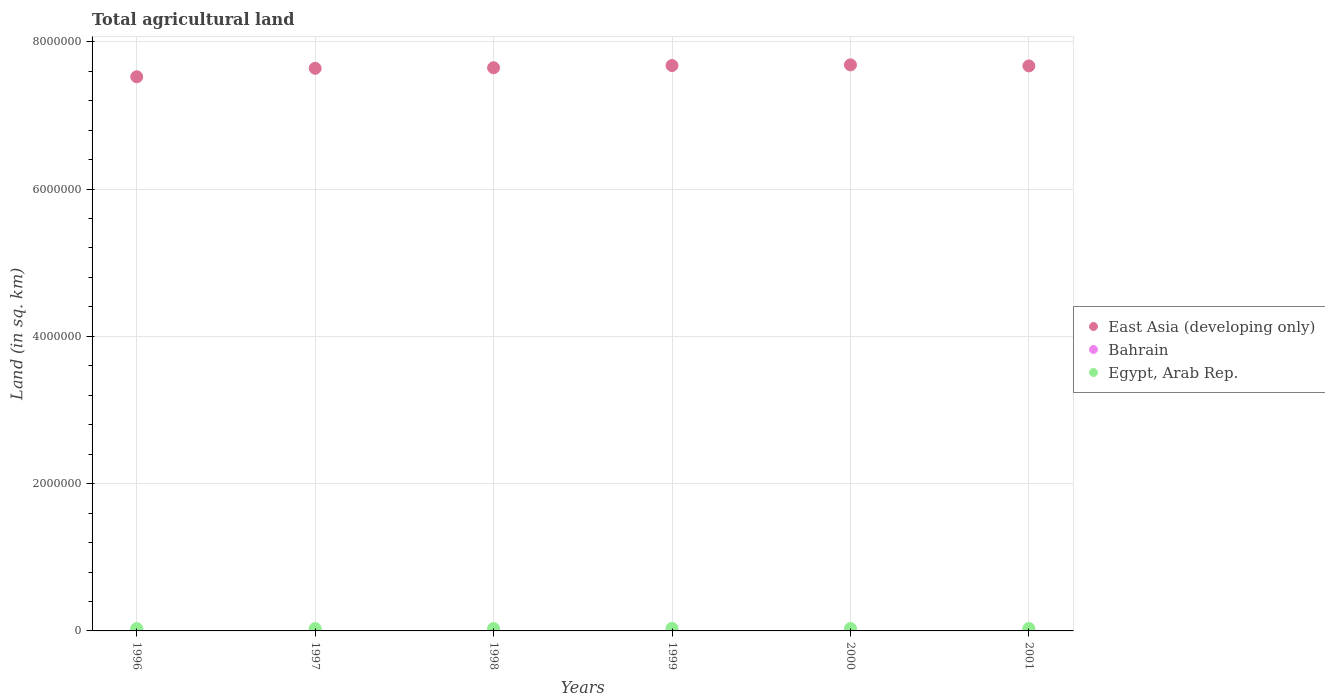How many different coloured dotlines are there?
Ensure brevity in your answer.  3. Across all years, what is the minimum total agricultural land in East Asia (developing only)?
Offer a terse response. 7.52e+06. In which year was the total agricultural land in Bahrain minimum?
Your answer should be compact. 1996. What is the total total agricultural land in Egypt, Arab Rep. in the graph?
Offer a terse response. 1.98e+05. What is the difference between the total agricultural land in East Asia (developing only) in 1996 and that in 1997?
Ensure brevity in your answer.  -1.15e+05. What is the difference between the total agricultural land in East Asia (developing only) in 1998 and the total agricultural land in Egypt, Arab Rep. in 1999?
Give a very brief answer. 7.61e+06. What is the average total agricultural land in Bahrain per year?
Your response must be concise. 92.33. In the year 1999, what is the difference between the total agricultural land in Egypt, Arab Rep. and total agricultural land in Bahrain?
Offer a very short reply. 3.47e+04. What is the ratio of the total agricultural land in East Asia (developing only) in 1996 to that in 2001?
Your answer should be very brief. 0.98. Is the total agricultural land in Bahrain in 1998 less than that in 2001?
Provide a short and direct response. Yes. What is the difference between the highest and the second highest total agricultural land in Egypt, Arab Rep.?
Your answer should be very brief. 1450. What is the difference between the highest and the lowest total agricultural land in Bahrain?
Keep it short and to the point. 10. In how many years, is the total agricultural land in East Asia (developing only) greater than the average total agricultural land in East Asia (developing only) taken over all years?
Ensure brevity in your answer.  4. Is the total agricultural land in East Asia (developing only) strictly less than the total agricultural land in Egypt, Arab Rep. over the years?
Your response must be concise. No. How many years are there in the graph?
Give a very brief answer. 6. Are the values on the major ticks of Y-axis written in scientific E-notation?
Keep it short and to the point. No. Does the graph contain any zero values?
Give a very brief answer. No. Does the graph contain grids?
Ensure brevity in your answer.  Yes. How many legend labels are there?
Your response must be concise. 3. How are the legend labels stacked?
Your answer should be very brief. Vertical. What is the title of the graph?
Make the answer very short. Total agricultural land. What is the label or title of the X-axis?
Offer a terse response. Years. What is the label or title of the Y-axis?
Provide a succinct answer. Land (in sq. km). What is the Land (in sq. km) in East Asia (developing only) in 1996?
Provide a short and direct response. 7.52e+06. What is the Land (in sq. km) of Egypt, Arab Rep. in 1996?
Your answer should be very brief. 3.18e+04. What is the Land (in sq. km) of East Asia (developing only) in 1997?
Your response must be concise. 7.64e+06. What is the Land (in sq. km) of Egypt, Arab Rep. in 1997?
Provide a short and direct response. 3.24e+04. What is the Land (in sq. km) in East Asia (developing only) in 1998?
Offer a very short reply. 7.65e+06. What is the Land (in sq. km) in Bahrain in 1998?
Your response must be concise. 90. What is the Land (in sq. km) in Egypt, Arab Rep. in 1998?
Give a very brief answer. 3.26e+04. What is the Land (in sq. km) of East Asia (developing only) in 1999?
Provide a short and direct response. 7.68e+06. What is the Land (in sq. km) in Bahrain in 1999?
Provide a short and direct response. 100. What is the Land (in sq. km) in Egypt, Arab Rep. in 1999?
Offer a very short reply. 3.48e+04. What is the Land (in sq. km) in East Asia (developing only) in 2000?
Your response must be concise. 7.69e+06. What is the Land (in sq. km) of Bahrain in 2000?
Provide a succinct answer. 92. What is the Land (in sq. km) in Egypt, Arab Rep. in 2000?
Give a very brief answer. 3.29e+04. What is the Land (in sq. km) in East Asia (developing only) in 2001?
Provide a succinct answer. 7.67e+06. What is the Land (in sq. km) in Bahrain in 2001?
Make the answer very short. 92. What is the Land (in sq. km) of Egypt, Arab Rep. in 2001?
Provide a succinct answer. 3.34e+04. Across all years, what is the maximum Land (in sq. km) of East Asia (developing only)?
Your response must be concise. 7.69e+06. Across all years, what is the maximum Land (in sq. km) of Egypt, Arab Rep.?
Offer a very short reply. 3.48e+04. Across all years, what is the minimum Land (in sq. km) of East Asia (developing only)?
Your response must be concise. 7.52e+06. Across all years, what is the minimum Land (in sq. km) in Egypt, Arab Rep.?
Provide a succinct answer. 3.18e+04. What is the total Land (in sq. km) in East Asia (developing only) in the graph?
Provide a succinct answer. 4.58e+07. What is the total Land (in sq. km) in Bahrain in the graph?
Offer a very short reply. 554. What is the total Land (in sq. km) of Egypt, Arab Rep. in the graph?
Make the answer very short. 1.98e+05. What is the difference between the Land (in sq. km) in East Asia (developing only) in 1996 and that in 1997?
Your response must be concise. -1.15e+05. What is the difference between the Land (in sq. km) of Bahrain in 1996 and that in 1997?
Make the answer very short. 0. What is the difference between the Land (in sq. km) of Egypt, Arab Rep. in 1996 and that in 1997?
Give a very brief answer. -684.6. What is the difference between the Land (in sq. km) of East Asia (developing only) in 1996 and that in 1998?
Ensure brevity in your answer.  -1.22e+05. What is the difference between the Land (in sq. km) of Bahrain in 1996 and that in 1998?
Your answer should be very brief. 0. What is the difference between the Land (in sq. km) in Egypt, Arab Rep. in 1996 and that in 1998?
Offer a very short reply. -831.6. What is the difference between the Land (in sq. km) of East Asia (developing only) in 1996 and that in 1999?
Offer a very short reply. -1.52e+05. What is the difference between the Land (in sq. km) in Bahrain in 1996 and that in 1999?
Ensure brevity in your answer.  -10. What is the difference between the Land (in sq. km) of Egypt, Arab Rep. in 1996 and that in 1999?
Your answer should be compact. -3065.4. What is the difference between the Land (in sq. km) of East Asia (developing only) in 1996 and that in 2000?
Make the answer very short. -1.61e+05. What is the difference between the Land (in sq. km) of Bahrain in 1996 and that in 2000?
Your answer should be compact. -2. What is the difference between the Land (in sq. km) in Egypt, Arab Rep. in 1996 and that in 2000?
Ensure brevity in your answer.  -1145.4. What is the difference between the Land (in sq. km) in East Asia (developing only) in 1996 and that in 2001?
Your response must be concise. -1.47e+05. What is the difference between the Land (in sq. km) of Bahrain in 1996 and that in 2001?
Give a very brief answer. -2. What is the difference between the Land (in sq. km) of Egypt, Arab Rep. in 1996 and that in 2001?
Ensure brevity in your answer.  -1615.4. What is the difference between the Land (in sq. km) of East Asia (developing only) in 1997 and that in 1998?
Provide a short and direct response. -7489. What is the difference between the Land (in sq. km) of Egypt, Arab Rep. in 1997 and that in 1998?
Give a very brief answer. -147. What is the difference between the Land (in sq. km) in East Asia (developing only) in 1997 and that in 1999?
Provide a succinct answer. -3.74e+04. What is the difference between the Land (in sq. km) in Bahrain in 1997 and that in 1999?
Keep it short and to the point. -10. What is the difference between the Land (in sq. km) in Egypt, Arab Rep. in 1997 and that in 1999?
Provide a short and direct response. -2380.8. What is the difference between the Land (in sq. km) of East Asia (developing only) in 1997 and that in 2000?
Provide a short and direct response. -4.65e+04. What is the difference between the Land (in sq. km) of Bahrain in 1997 and that in 2000?
Your response must be concise. -2. What is the difference between the Land (in sq. km) of Egypt, Arab Rep. in 1997 and that in 2000?
Provide a short and direct response. -460.8. What is the difference between the Land (in sq. km) in East Asia (developing only) in 1997 and that in 2001?
Make the answer very short. -3.25e+04. What is the difference between the Land (in sq. km) in Bahrain in 1997 and that in 2001?
Ensure brevity in your answer.  -2. What is the difference between the Land (in sq. km) of Egypt, Arab Rep. in 1997 and that in 2001?
Provide a short and direct response. -930.8. What is the difference between the Land (in sq. km) in East Asia (developing only) in 1998 and that in 1999?
Make the answer very short. -2.99e+04. What is the difference between the Land (in sq. km) in Bahrain in 1998 and that in 1999?
Provide a short and direct response. -10. What is the difference between the Land (in sq. km) of Egypt, Arab Rep. in 1998 and that in 1999?
Keep it short and to the point. -2233.8. What is the difference between the Land (in sq. km) in East Asia (developing only) in 1998 and that in 2000?
Offer a terse response. -3.90e+04. What is the difference between the Land (in sq. km) of Egypt, Arab Rep. in 1998 and that in 2000?
Keep it short and to the point. -313.8. What is the difference between the Land (in sq. km) of East Asia (developing only) in 1998 and that in 2001?
Offer a very short reply. -2.50e+04. What is the difference between the Land (in sq. km) of Bahrain in 1998 and that in 2001?
Provide a succinct answer. -2. What is the difference between the Land (in sq. km) in Egypt, Arab Rep. in 1998 and that in 2001?
Provide a short and direct response. -783.8. What is the difference between the Land (in sq. km) of East Asia (developing only) in 1999 and that in 2000?
Offer a terse response. -9175.1. What is the difference between the Land (in sq. km) of Egypt, Arab Rep. in 1999 and that in 2000?
Make the answer very short. 1920. What is the difference between the Land (in sq. km) in East Asia (developing only) in 1999 and that in 2001?
Your answer should be very brief. 4894.9. What is the difference between the Land (in sq. km) in Egypt, Arab Rep. in 1999 and that in 2001?
Provide a short and direct response. 1450. What is the difference between the Land (in sq. km) in East Asia (developing only) in 2000 and that in 2001?
Make the answer very short. 1.41e+04. What is the difference between the Land (in sq. km) in Egypt, Arab Rep. in 2000 and that in 2001?
Provide a succinct answer. -470. What is the difference between the Land (in sq. km) of East Asia (developing only) in 1996 and the Land (in sq. km) of Bahrain in 1997?
Offer a very short reply. 7.52e+06. What is the difference between the Land (in sq. km) in East Asia (developing only) in 1996 and the Land (in sq. km) in Egypt, Arab Rep. in 1997?
Your response must be concise. 7.49e+06. What is the difference between the Land (in sq. km) of Bahrain in 1996 and the Land (in sq. km) of Egypt, Arab Rep. in 1997?
Provide a short and direct response. -3.24e+04. What is the difference between the Land (in sq. km) in East Asia (developing only) in 1996 and the Land (in sq. km) in Bahrain in 1998?
Make the answer very short. 7.52e+06. What is the difference between the Land (in sq. km) in East Asia (developing only) in 1996 and the Land (in sq. km) in Egypt, Arab Rep. in 1998?
Your answer should be compact. 7.49e+06. What is the difference between the Land (in sq. km) in Bahrain in 1996 and the Land (in sq. km) in Egypt, Arab Rep. in 1998?
Ensure brevity in your answer.  -3.25e+04. What is the difference between the Land (in sq. km) in East Asia (developing only) in 1996 and the Land (in sq. km) in Bahrain in 1999?
Give a very brief answer. 7.52e+06. What is the difference between the Land (in sq. km) in East Asia (developing only) in 1996 and the Land (in sq. km) in Egypt, Arab Rep. in 1999?
Give a very brief answer. 7.49e+06. What is the difference between the Land (in sq. km) in Bahrain in 1996 and the Land (in sq. km) in Egypt, Arab Rep. in 1999?
Your answer should be very brief. -3.47e+04. What is the difference between the Land (in sq. km) of East Asia (developing only) in 1996 and the Land (in sq. km) of Bahrain in 2000?
Keep it short and to the point. 7.52e+06. What is the difference between the Land (in sq. km) in East Asia (developing only) in 1996 and the Land (in sq. km) in Egypt, Arab Rep. in 2000?
Offer a terse response. 7.49e+06. What is the difference between the Land (in sq. km) of Bahrain in 1996 and the Land (in sq. km) of Egypt, Arab Rep. in 2000?
Offer a terse response. -3.28e+04. What is the difference between the Land (in sq. km) in East Asia (developing only) in 1996 and the Land (in sq. km) in Bahrain in 2001?
Your answer should be very brief. 7.52e+06. What is the difference between the Land (in sq. km) of East Asia (developing only) in 1996 and the Land (in sq. km) of Egypt, Arab Rep. in 2001?
Provide a succinct answer. 7.49e+06. What is the difference between the Land (in sq. km) of Bahrain in 1996 and the Land (in sq. km) of Egypt, Arab Rep. in 2001?
Provide a succinct answer. -3.33e+04. What is the difference between the Land (in sq. km) of East Asia (developing only) in 1997 and the Land (in sq. km) of Bahrain in 1998?
Give a very brief answer. 7.64e+06. What is the difference between the Land (in sq. km) in East Asia (developing only) in 1997 and the Land (in sq. km) in Egypt, Arab Rep. in 1998?
Keep it short and to the point. 7.61e+06. What is the difference between the Land (in sq. km) of Bahrain in 1997 and the Land (in sq. km) of Egypt, Arab Rep. in 1998?
Ensure brevity in your answer.  -3.25e+04. What is the difference between the Land (in sq. km) of East Asia (developing only) in 1997 and the Land (in sq. km) of Bahrain in 1999?
Your answer should be compact. 7.64e+06. What is the difference between the Land (in sq. km) of East Asia (developing only) in 1997 and the Land (in sq. km) of Egypt, Arab Rep. in 1999?
Ensure brevity in your answer.  7.61e+06. What is the difference between the Land (in sq. km) in Bahrain in 1997 and the Land (in sq. km) in Egypt, Arab Rep. in 1999?
Provide a succinct answer. -3.47e+04. What is the difference between the Land (in sq. km) in East Asia (developing only) in 1997 and the Land (in sq. km) in Bahrain in 2000?
Keep it short and to the point. 7.64e+06. What is the difference between the Land (in sq. km) in East Asia (developing only) in 1997 and the Land (in sq. km) in Egypt, Arab Rep. in 2000?
Give a very brief answer. 7.61e+06. What is the difference between the Land (in sq. km) of Bahrain in 1997 and the Land (in sq. km) of Egypt, Arab Rep. in 2000?
Give a very brief answer. -3.28e+04. What is the difference between the Land (in sq. km) in East Asia (developing only) in 1997 and the Land (in sq. km) in Bahrain in 2001?
Offer a terse response. 7.64e+06. What is the difference between the Land (in sq. km) in East Asia (developing only) in 1997 and the Land (in sq. km) in Egypt, Arab Rep. in 2001?
Provide a short and direct response. 7.61e+06. What is the difference between the Land (in sq. km) in Bahrain in 1997 and the Land (in sq. km) in Egypt, Arab Rep. in 2001?
Ensure brevity in your answer.  -3.33e+04. What is the difference between the Land (in sq. km) of East Asia (developing only) in 1998 and the Land (in sq. km) of Bahrain in 1999?
Provide a short and direct response. 7.65e+06. What is the difference between the Land (in sq. km) of East Asia (developing only) in 1998 and the Land (in sq. km) of Egypt, Arab Rep. in 1999?
Your response must be concise. 7.61e+06. What is the difference between the Land (in sq. km) of Bahrain in 1998 and the Land (in sq. km) of Egypt, Arab Rep. in 1999?
Ensure brevity in your answer.  -3.47e+04. What is the difference between the Land (in sq. km) in East Asia (developing only) in 1998 and the Land (in sq. km) in Bahrain in 2000?
Provide a succinct answer. 7.65e+06. What is the difference between the Land (in sq. km) of East Asia (developing only) in 1998 and the Land (in sq. km) of Egypt, Arab Rep. in 2000?
Give a very brief answer. 7.61e+06. What is the difference between the Land (in sq. km) of Bahrain in 1998 and the Land (in sq. km) of Egypt, Arab Rep. in 2000?
Provide a succinct answer. -3.28e+04. What is the difference between the Land (in sq. km) of East Asia (developing only) in 1998 and the Land (in sq. km) of Bahrain in 2001?
Offer a very short reply. 7.65e+06. What is the difference between the Land (in sq. km) in East Asia (developing only) in 1998 and the Land (in sq. km) in Egypt, Arab Rep. in 2001?
Give a very brief answer. 7.61e+06. What is the difference between the Land (in sq. km) of Bahrain in 1998 and the Land (in sq. km) of Egypt, Arab Rep. in 2001?
Offer a very short reply. -3.33e+04. What is the difference between the Land (in sq. km) in East Asia (developing only) in 1999 and the Land (in sq. km) in Bahrain in 2000?
Keep it short and to the point. 7.68e+06. What is the difference between the Land (in sq. km) of East Asia (developing only) in 1999 and the Land (in sq. km) of Egypt, Arab Rep. in 2000?
Offer a very short reply. 7.64e+06. What is the difference between the Land (in sq. km) of Bahrain in 1999 and the Land (in sq. km) of Egypt, Arab Rep. in 2000?
Give a very brief answer. -3.28e+04. What is the difference between the Land (in sq. km) in East Asia (developing only) in 1999 and the Land (in sq. km) in Bahrain in 2001?
Offer a terse response. 7.68e+06. What is the difference between the Land (in sq. km) of East Asia (developing only) in 1999 and the Land (in sq. km) of Egypt, Arab Rep. in 2001?
Your answer should be compact. 7.64e+06. What is the difference between the Land (in sq. km) of Bahrain in 1999 and the Land (in sq. km) of Egypt, Arab Rep. in 2001?
Keep it short and to the point. -3.33e+04. What is the difference between the Land (in sq. km) in East Asia (developing only) in 2000 and the Land (in sq. km) in Bahrain in 2001?
Keep it short and to the point. 7.69e+06. What is the difference between the Land (in sq. km) of East Asia (developing only) in 2000 and the Land (in sq. km) of Egypt, Arab Rep. in 2001?
Offer a very short reply. 7.65e+06. What is the difference between the Land (in sq. km) of Bahrain in 2000 and the Land (in sq. km) of Egypt, Arab Rep. in 2001?
Give a very brief answer. -3.33e+04. What is the average Land (in sq. km) in East Asia (developing only) per year?
Your response must be concise. 7.64e+06. What is the average Land (in sq. km) of Bahrain per year?
Your answer should be very brief. 92.33. What is the average Land (in sq. km) in Egypt, Arab Rep. per year?
Your response must be concise. 3.30e+04. In the year 1996, what is the difference between the Land (in sq. km) in East Asia (developing only) and Land (in sq. km) in Bahrain?
Keep it short and to the point. 7.52e+06. In the year 1996, what is the difference between the Land (in sq. km) of East Asia (developing only) and Land (in sq. km) of Egypt, Arab Rep.?
Offer a very short reply. 7.49e+06. In the year 1996, what is the difference between the Land (in sq. km) of Bahrain and Land (in sq. km) of Egypt, Arab Rep.?
Ensure brevity in your answer.  -3.17e+04. In the year 1997, what is the difference between the Land (in sq. km) of East Asia (developing only) and Land (in sq. km) of Bahrain?
Your answer should be compact. 7.64e+06. In the year 1997, what is the difference between the Land (in sq. km) of East Asia (developing only) and Land (in sq. km) of Egypt, Arab Rep.?
Keep it short and to the point. 7.61e+06. In the year 1997, what is the difference between the Land (in sq. km) in Bahrain and Land (in sq. km) in Egypt, Arab Rep.?
Your answer should be compact. -3.24e+04. In the year 1998, what is the difference between the Land (in sq. km) of East Asia (developing only) and Land (in sq. km) of Bahrain?
Offer a very short reply. 7.65e+06. In the year 1998, what is the difference between the Land (in sq. km) of East Asia (developing only) and Land (in sq. km) of Egypt, Arab Rep.?
Keep it short and to the point. 7.61e+06. In the year 1998, what is the difference between the Land (in sq. km) of Bahrain and Land (in sq. km) of Egypt, Arab Rep.?
Your answer should be very brief. -3.25e+04. In the year 1999, what is the difference between the Land (in sq. km) in East Asia (developing only) and Land (in sq. km) in Bahrain?
Make the answer very short. 7.68e+06. In the year 1999, what is the difference between the Land (in sq. km) in East Asia (developing only) and Land (in sq. km) in Egypt, Arab Rep.?
Offer a very short reply. 7.64e+06. In the year 1999, what is the difference between the Land (in sq. km) of Bahrain and Land (in sq. km) of Egypt, Arab Rep.?
Make the answer very short. -3.47e+04. In the year 2000, what is the difference between the Land (in sq. km) in East Asia (developing only) and Land (in sq. km) in Bahrain?
Keep it short and to the point. 7.69e+06. In the year 2000, what is the difference between the Land (in sq. km) of East Asia (developing only) and Land (in sq. km) of Egypt, Arab Rep.?
Ensure brevity in your answer.  7.65e+06. In the year 2000, what is the difference between the Land (in sq. km) of Bahrain and Land (in sq. km) of Egypt, Arab Rep.?
Offer a terse response. -3.28e+04. In the year 2001, what is the difference between the Land (in sq. km) in East Asia (developing only) and Land (in sq. km) in Bahrain?
Provide a succinct answer. 7.67e+06. In the year 2001, what is the difference between the Land (in sq. km) of East Asia (developing only) and Land (in sq. km) of Egypt, Arab Rep.?
Offer a terse response. 7.64e+06. In the year 2001, what is the difference between the Land (in sq. km) of Bahrain and Land (in sq. km) of Egypt, Arab Rep.?
Offer a very short reply. -3.33e+04. What is the ratio of the Land (in sq. km) in Egypt, Arab Rep. in 1996 to that in 1997?
Keep it short and to the point. 0.98. What is the ratio of the Land (in sq. km) of East Asia (developing only) in 1996 to that in 1998?
Provide a succinct answer. 0.98. What is the ratio of the Land (in sq. km) of Egypt, Arab Rep. in 1996 to that in 1998?
Offer a very short reply. 0.97. What is the ratio of the Land (in sq. km) of East Asia (developing only) in 1996 to that in 1999?
Give a very brief answer. 0.98. What is the ratio of the Land (in sq. km) in Egypt, Arab Rep. in 1996 to that in 1999?
Make the answer very short. 0.91. What is the ratio of the Land (in sq. km) of East Asia (developing only) in 1996 to that in 2000?
Your answer should be compact. 0.98. What is the ratio of the Land (in sq. km) in Bahrain in 1996 to that in 2000?
Your answer should be compact. 0.98. What is the ratio of the Land (in sq. km) in Egypt, Arab Rep. in 1996 to that in 2000?
Your answer should be compact. 0.97. What is the ratio of the Land (in sq. km) in East Asia (developing only) in 1996 to that in 2001?
Give a very brief answer. 0.98. What is the ratio of the Land (in sq. km) of Bahrain in 1996 to that in 2001?
Ensure brevity in your answer.  0.98. What is the ratio of the Land (in sq. km) of Egypt, Arab Rep. in 1996 to that in 2001?
Your response must be concise. 0.95. What is the ratio of the Land (in sq. km) of Egypt, Arab Rep. in 1997 to that in 1998?
Your answer should be very brief. 1. What is the ratio of the Land (in sq. km) of Egypt, Arab Rep. in 1997 to that in 1999?
Give a very brief answer. 0.93. What is the ratio of the Land (in sq. km) of Bahrain in 1997 to that in 2000?
Offer a very short reply. 0.98. What is the ratio of the Land (in sq. km) in East Asia (developing only) in 1997 to that in 2001?
Offer a very short reply. 1. What is the ratio of the Land (in sq. km) in Bahrain in 1997 to that in 2001?
Your answer should be compact. 0.98. What is the ratio of the Land (in sq. km) in Egypt, Arab Rep. in 1997 to that in 2001?
Your answer should be compact. 0.97. What is the ratio of the Land (in sq. km) in Bahrain in 1998 to that in 1999?
Offer a terse response. 0.9. What is the ratio of the Land (in sq. km) of Egypt, Arab Rep. in 1998 to that in 1999?
Your answer should be compact. 0.94. What is the ratio of the Land (in sq. km) in East Asia (developing only) in 1998 to that in 2000?
Make the answer very short. 0.99. What is the ratio of the Land (in sq. km) of Bahrain in 1998 to that in 2000?
Give a very brief answer. 0.98. What is the ratio of the Land (in sq. km) in Bahrain in 1998 to that in 2001?
Your answer should be very brief. 0.98. What is the ratio of the Land (in sq. km) in Egypt, Arab Rep. in 1998 to that in 2001?
Your answer should be compact. 0.98. What is the ratio of the Land (in sq. km) of Bahrain in 1999 to that in 2000?
Your answer should be compact. 1.09. What is the ratio of the Land (in sq. km) in Egypt, Arab Rep. in 1999 to that in 2000?
Provide a succinct answer. 1.06. What is the ratio of the Land (in sq. km) of East Asia (developing only) in 1999 to that in 2001?
Offer a terse response. 1. What is the ratio of the Land (in sq. km) in Bahrain in 1999 to that in 2001?
Your answer should be very brief. 1.09. What is the ratio of the Land (in sq. km) in Egypt, Arab Rep. in 1999 to that in 2001?
Give a very brief answer. 1.04. What is the ratio of the Land (in sq. km) in Bahrain in 2000 to that in 2001?
Your response must be concise. 1. What is the ratio of the Land (in sq. km) of Egypt, Arab Rep. in 2000 to that in 2001?
Offer a very short reply. 0.99. What is the difference between the highest and the second highest Land (in sq. km) of East Asia (developing only)?
Ensure brevity in your answer.  9175.1. What is the difference between the highest and the second highest Land (in sq. km) of Bahrain?
Offer a terse response. 8. What is the difference between the highest and the second highest Land (in sq. km) in Egypt, Arab Rep.?
Your answer should be compact. 1450. What is the difference between the highest and the lowest Land (in sq. km) in East Asia (developing only)?
Make the answer very short. 1.61e+05. What is the difference between the highest and the lowest Land (in sq. km) of Egypt, Arab Rep.?
Your response must be concise. 3065.4. 